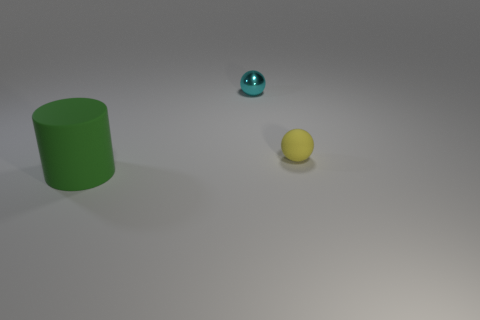There is a thing that is both to the left of the small yellow ball and behind the green object; what is its material?
Your answer should be compact. Metal. There is a thing that is made of the same material as the tiny yellow ball; what is its shape?
Your answer should be compact. Cylinder. Is there anything else that is the same color as the tiny matte object?
Your response must be concise. No. Are there more small things right of the yellow object than cylinders?
Provide a short and direct response. No. What is the green object made of?
Your response must be concise. Rubber. What number of rubber cylinders have the same size as the yellow sphere?
Your response must be concise. 0. Is the number of yellow objects that are on the right side of the tiny matte object the same as the number of small balls that are to the left of the green object?
Ensure brevity in your answer.  Yes. Do the cylinder and the tiny cyan object have the same material?
Offer a terse response. No. Are there any yellow balls behind the tiny thing behind the tiny yellow ball?
Provide a short and direct response. No. Is there a big rubber object of the same shape as the tiny yellow thing?
Offer a terse response. No. 